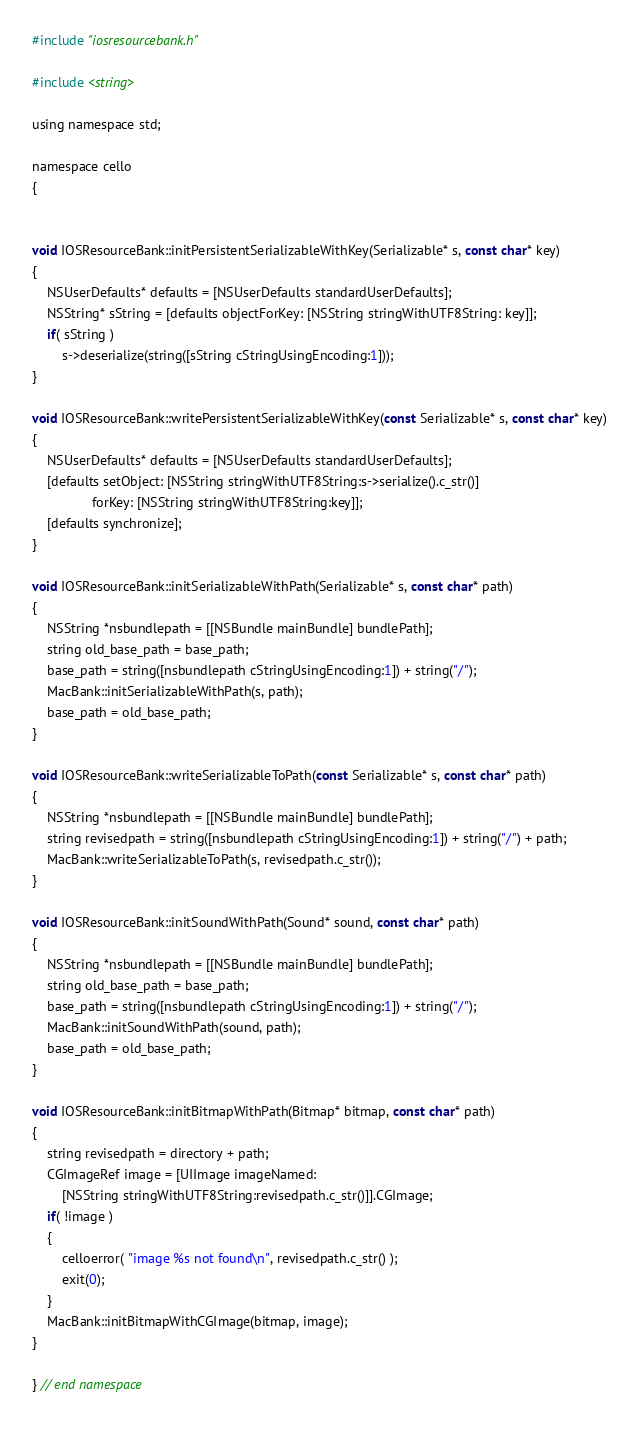<code> <loc_0><loc_0><loc_500><loc_500><_ObjectiveC_>#include "iosresourcebank.h"

#include <string>

using namespace std;

namespace cello
{


void IOSResourceBank::initPersistentSerializableWithKey(Serializable* s, const char* key)
{
	NSUserDefaults* defaults = [NSUserDefaults standardUserDefaults];
	NSString* sString = [defaults objectForKey: [NSString stringWithUTF8String: key]];
	if( sString )
		s->deserialize(string([sString cStringUsingEncoding:1]));
}

void IOSResourceBank::writePersistentSerializableWithKey(const Serializable* s, const char* key)
{
	NSUserDefaults* defaults = [NSUserDefaults standardUserDefaults];
	[defaults setObject: [NSString stringWithUTF8String:s->serialize().c_str()]
				forKey: [NSString stringWithUTF8String:key]];
	[defaults synchronize];
}

void IOSResourceBank::initSerializableWithPath(Serializable* s, const char* path)
{
	NSString *nsbundlepath = [[NSBundle mainBundle] bundlePath];
	string old_base_path = base_path;
	base_path = string([nsbundlepath cStringUsingEncoding:1]) + string("/");
	MacBank::initSerializableWithPath(s, path);
	base_path = old_base_path;
}

void IOSResourceBank::writeSerializableToPath(const Serializable* s, const char* path)
{
	NSString *nsbundlepath = [[NSBundle mainBundle] bundlePath];
	string revisedpath = string([nsbundlepath cStringUsingEncoding:1]) + string("/") + path;
	MacBank::writeSerializableToPath(s, revisedpath.c_str());
}

void IOSResourceBank::initSoundWithPath(Sound* sound, const char* path)
{
	NSString *nsbundlepath = [[NSBundle mainBundle] bundlePath];
	string old_base_path = base_path;
	base_path = string([nsbundlepath cStringUsingEncoding:1]) + string("/");
	MacBank::initSoundWithPath(sound, path);
	base_path = old_base_path;
}

void IOSResourceBank::initBitmapWithPath(Bitmap* bitmap, const char* path)
{
	string revisedpath = directory + path;
	CGImageRef image = [UIImage imageNamed:
		[NSString stringWithUTF8String:revisedpath.c_str()]].CGImage;
	if( !image )
	{
		celloerror( "image %s not found\n", revisedpath.c_str() );
		exit(0);
	}
	MacBank::initBitmapWithCGImage(bitmap, image);
}

} // end namespace


</code> 